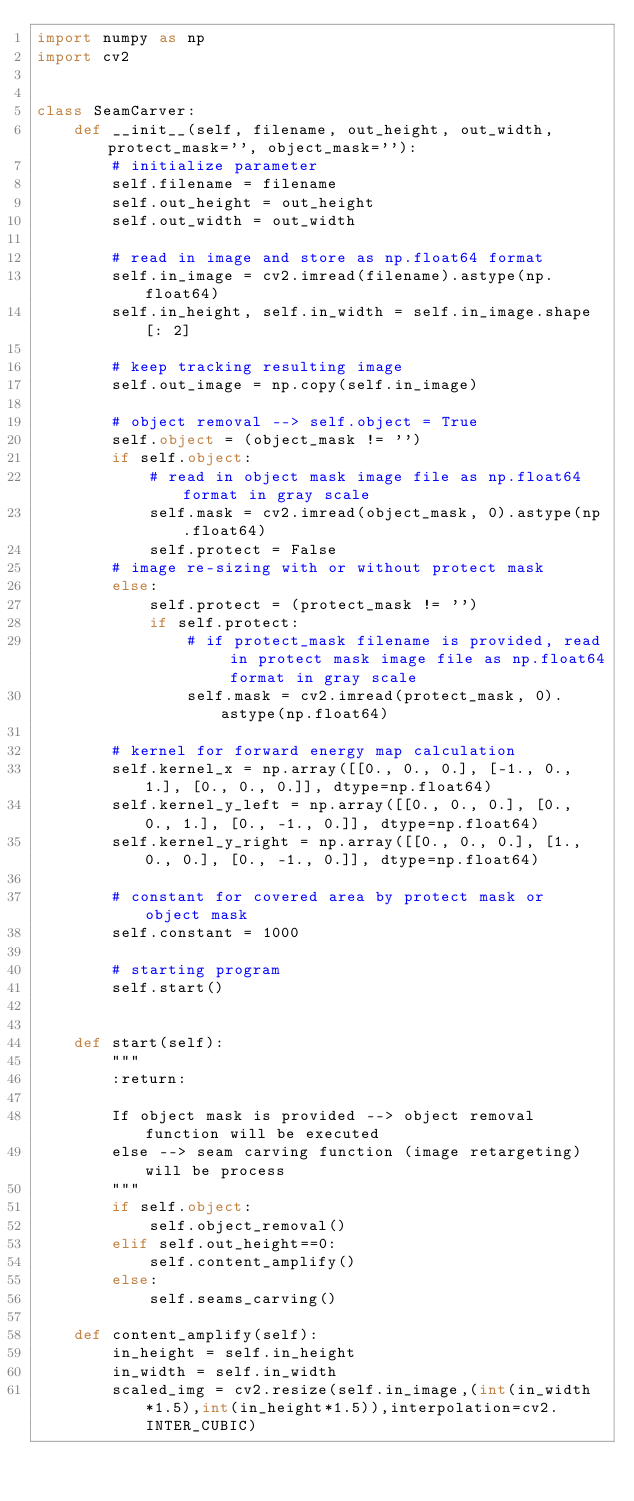<code> <loc_0><loc_0><loc_500><loc_500><_Python_>import numpy as np
import cv2


class SeamCarver:
    def __init__(self, filename, out_height, out_width, protect_mask='', object_mask=''):
        # initialize parameter
        self.filename = filename
        self.out_height = out_height
        self.out_width = out_width

        # read in image and store as np.float64 format
        self.in_image = cv2.imread(filename).astype(np.float64)
        self.in_height, self.in_width = self.in_image.shape[: 2]

        # keep tracking resulting image
        self.out_image = np.copy(self.in_image)

        # object removal --> self.object = True
        self.object = (object_mask != '')
        if self.object:
            # read in object mask image file as np.float64 format in gray scale
            self.mask = cv2.imread(object_mask, 0).astype(np.float64)
            self.protect = False
        # image re-sizing with or without protect mask
        else:
            self.protect = (protect_mask != '')
            if self.protect:
                # if protect_mask filename is provided, read in protect mask image file as np.float64 format in gray scale
                self.mask = cv2.imread(protect_mask, 0).astype(np.float64)

        # kernel for forward energy map calculation
        self.kernel_x = np.array([[0., 0., 0.], [-1., 0., 1.], [0., 0., 0.]], dtype=np.float64)
        self.kernel_y_left = np.array([[0., 0., 0.], [0., 0., 1.], [0., -1., 0.]], dtype=np.float64)
        self.kernel_y_right = np.array([[0., 0., 0.], [1., 0., 0.], [0., -1., 0.]], dtype=np.float64)

        # constant for covered area by protect mask or object mask
        self.constant = 1000

        # starting program
        self.start()


    def start(self):
        """
        :return:

        If object mask is provided --> object removal function will be executed
        else --> seam carving function (image retargeting) will be process
        """
        if self.object:
            self.object_removal()
        elif self.out_height==0:
            self.content_amplify()
        else:
            self.seams_carving()
            
    def content_amplify(self):
        in_height = self.in_height
        in_width = self.in_width
        scaled_img = cv2.resize(self.in_image,(int(in_width*1.5),int(in_height*1.5)),interpolation=cv2.INTER_CUBIC)</code> 